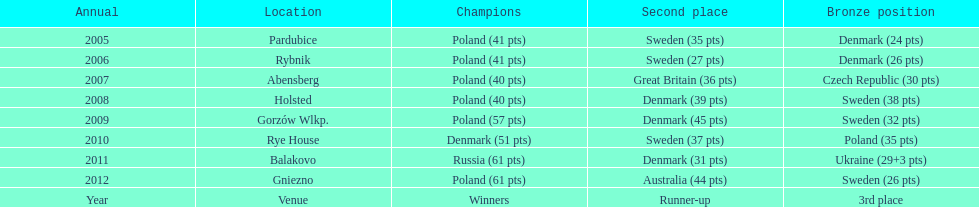What was the difference in final score between russia and denmark in 2011? 30. 